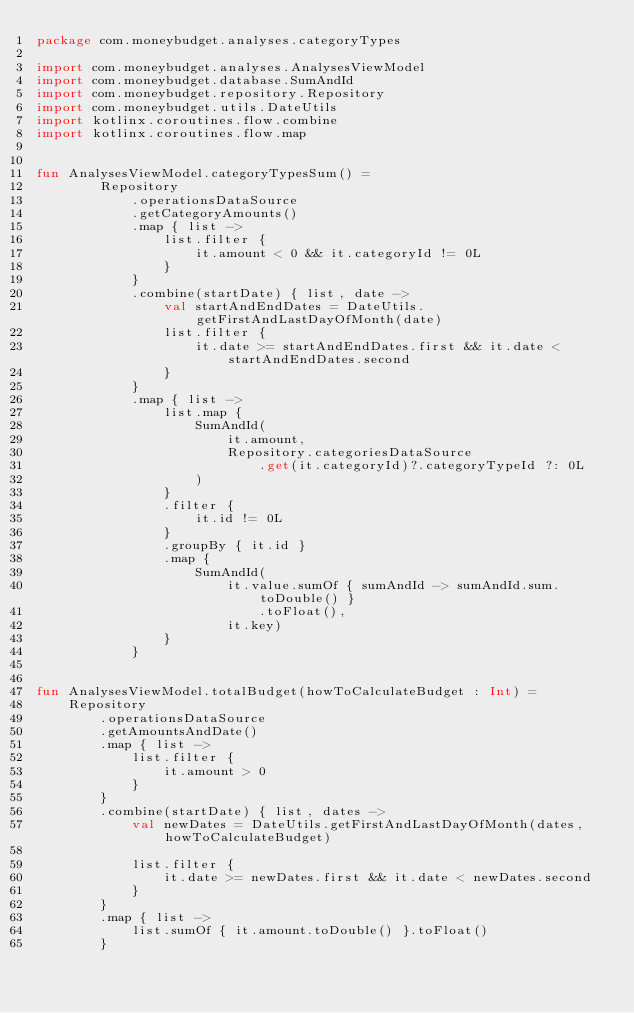<code> <loc_0><loc_0><loc_500><loc_500><_Kotlin_>package com.moneybudget.analyses.categoryTypes

import com.moneybudget.analyses.AnalysesViewModel
import com.moneybudget.database.SumAndId
import com.moneybudget.repository.Repository
import com.moneybudget.utils.DateUtils
import kotlinx.coroutines.flow.combine
import kotlinx.coroutines.flow.map


fun AnalysesViewModel.categoryTypesSum() =
        Repository
            .operationsDataSource
            .getCategoryAmounts()
            .map { list ->
                list.filter {
                    it.amount < 0 && it.categoryId != 0L
                }
            }
            .combine(startDate) { list, date ->
                val startAndEndDates = DateUtils.getFirstAndLastDayOfMonth(date)
                list.filter {
                    it.date >= startAndEndDates.first && it.date < startAndEndDates.second
                }
            }
            .map { list ->
                list.map {
                    SumAndId(
                        it.amount,
                        Repository.categoriesDataSource
                            .get(it.categoryId)?.categoryTypeId ?: 0L
                    )
                }
                .filter {
                    it.id != 0L
                }
                .groupBy { it.id }
                .map {
                    SumAndId(
                        it.value.sumOf { sumAndId -> sumAndId.sum.toDouble() }
                            .toFloat(),
                        it.key)
                }
            }


fun AnalysesViewModel.totalBudget(howToCalculateBudget : Int) =
    Repository
        .operationsDataSource
        .getAmountsAndDate()
        .map { list ->
            list.filter {
                it.amount > 0
            }
        }
        .combine(startDate) { list, dates ->
            val newDates = DateUtils.getFirstAndLastDayOfMonth(dates, howToCalculateBudget)

            list.filter {
                it.date >= newDates.first && it.date < newDates.second
            }
        }
        .map { list ->
            list.sumOf { it.amount.toDouble() }.toFloat()
        }</code> 